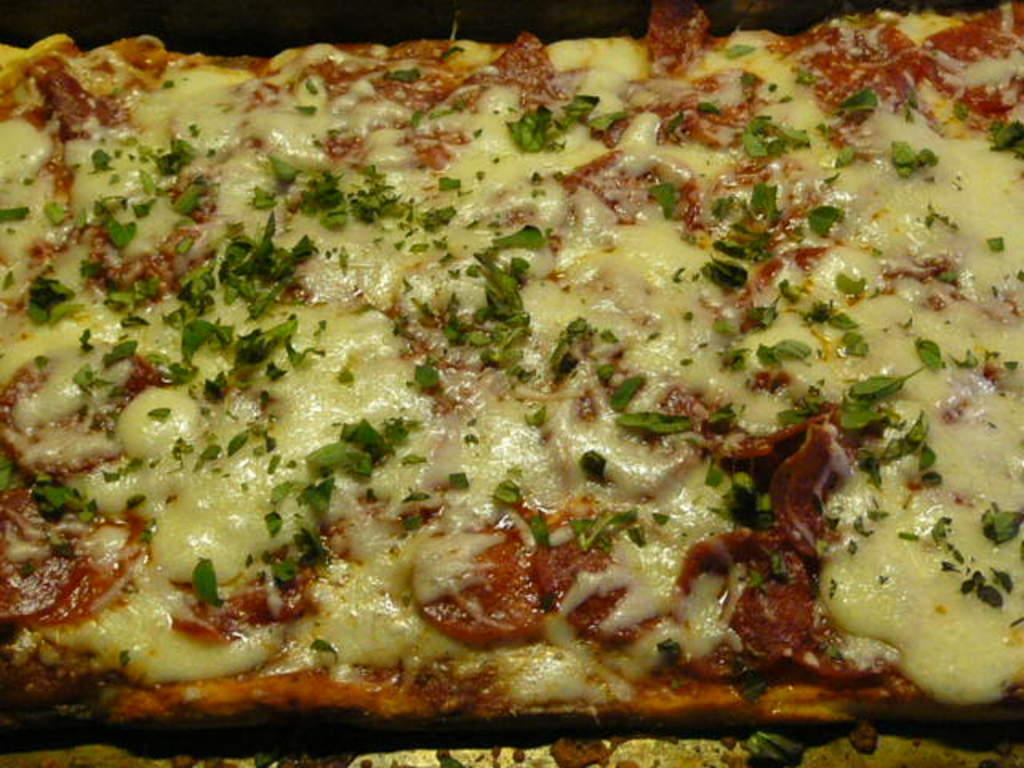What type of food item can be seen in the image? There is a food item in the image. What is a specific ingredient or topping on the food item? The food item has cheese on it. How is the food item presented or displayed in the image? The food item is on a tray. What is the tendency of spiders to spin webs in the image? There are no spiders or webs present in the image, so it is not possible to determine their tendency. 